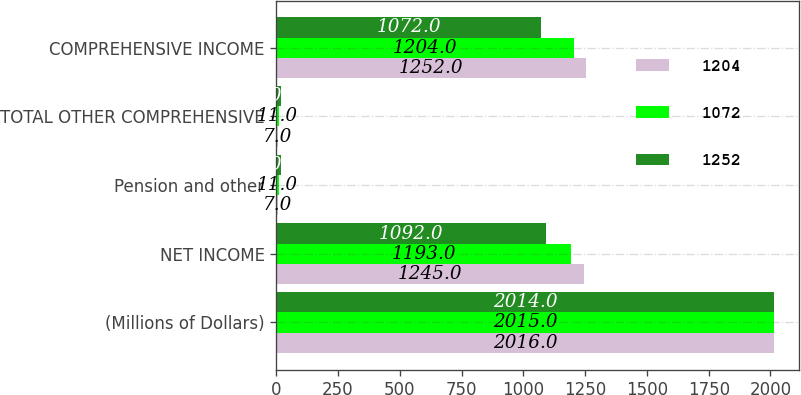Convert chart. <chart><loc_0><loc_0><loc_500><loc_500><stacked_bar_chart><ecel><fcel>(Millions of Dollars)<fcel>NET INCOME<fcel>Pension and other<fcel>TOTAL OTHER COMPREHENSIVE<fcel>COMPREHENSIVE INCOME<nl><fcel>1204<fcel>2016<fcel>1245<fcel>7<fcel>7<fcel>1252<nl><fcel>1072<fcel>2015<fcel>1193<fcel>11<fcel>11<fcel>1204<nl><fcel>1252<fcel>2014<fcel>1092<fcel>20<fcel>20<fcel>1072<nl></chart> 